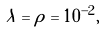<formula> <loc_0><loc_0><loc_500><loc_500>\lambda = \rho = 1 0 ^ { - 2 } ,</formula> 